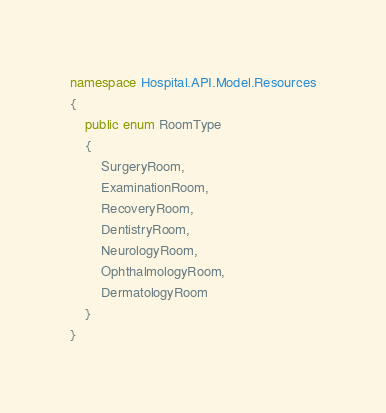Convert code to text. <code><loc_0><loc_0><loc_500><loc_500><_C#_>namespace Hospital.API.Model.Resources
{
    public enum RoomType
    {
        SurgeryRoom,
        ExaminationRoom,
        RecoveryRoom,
        DentistryRoom,
        NeurologyRoom,
        OphthalmologyRoom,
        DermatologyRoom
    }
}</code> 